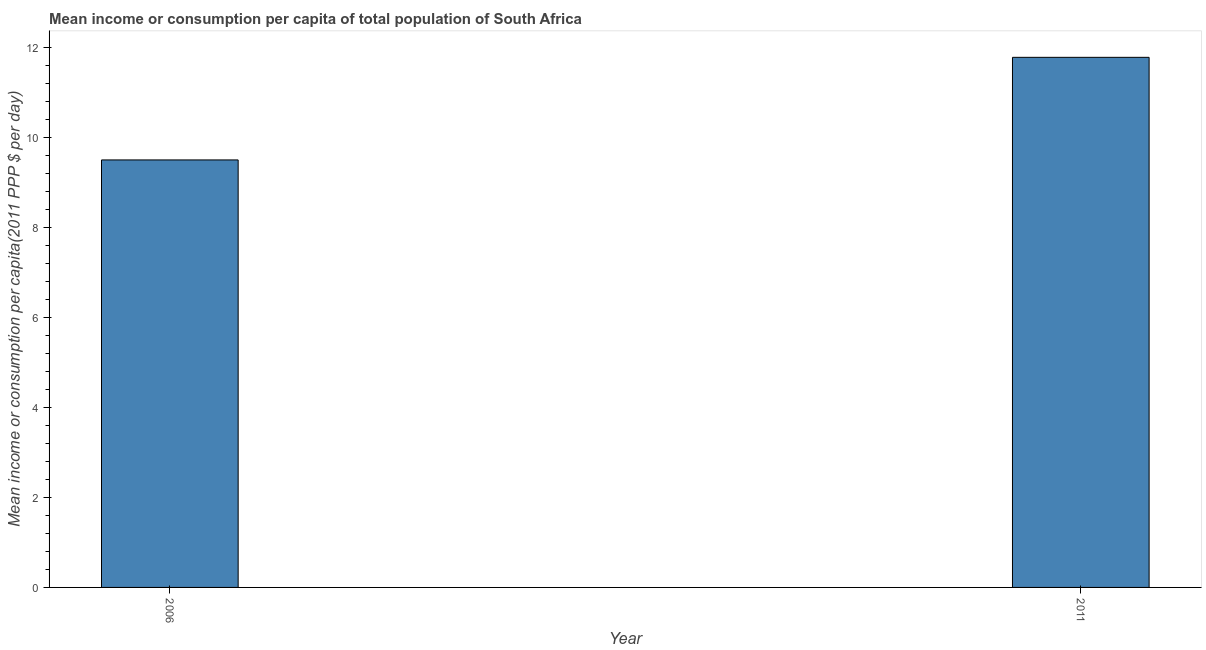Does the graph contain grids?
Provide a succinct answer. No. What is the title of the graph?
Provide a succinct answer. Mean income or consumption per capita of total population of South Africa. What is the label or title of the X-axis?
Offer a very short reply. Year. What is the label or title of the Y-axis?
Your response must be concise. Mean income or consumption per capita(2011 PPP $ per day). What is the mean income or consumption in 2006?
Give a very brief answer. 9.5. Across all years, what is the maximum mean income or consumption?
Keep it short and to the point. 11.78. Across all years, what is the minimum mean income or consumption?
Your answer should be very brief. 9.5. In which year was the mean income or consumption minimum?
Offer a very short reply. 2006. What is the sum of the mean income or consumption?
Give a very brief answer. 21.28. What is the difference between the mean income or consumption in 2006 and 2011?
Give a very brief answer. -2.28. What is the average mean income or consumption per year?
Make the answer very short. 10.64. What is the median mean income or consumption?
Offer a very short reply. 10.64. In how many years, is the mean income or consumption greater than 1.6 $?
Ensure brevity in your answer.  2. What is the ratio of the mean income or consumption in 2006 to that in 2011?
Ensure brevity in your answer.  0.81. Is the mean income or consumption in 2006 less than that in 2011?
Keep it short and to the point. Yes. In how many years, is the mean income or consumption greater than the average mean income or consumption taken over all years?
Offer a very short reply. 1. What is the difference between two consecutive major ticks on the Y-axis?
Provide a short and direct response. 2. What is the Mean income or consumption per capita(2011 PPP $ per day) of 2011?
Provide a short and direct response. 11.78. What is the difference between the Mean income or consumption per capita(2011 PPP $ per day) in 2006 and 2011?
Provide a short and direct response. -2.28. What is the ratio of the Mean income or consumption per capita(2011 PPP $ per day) in 2006 to that in 2011?
Your answer should be very brief. 0.81. 